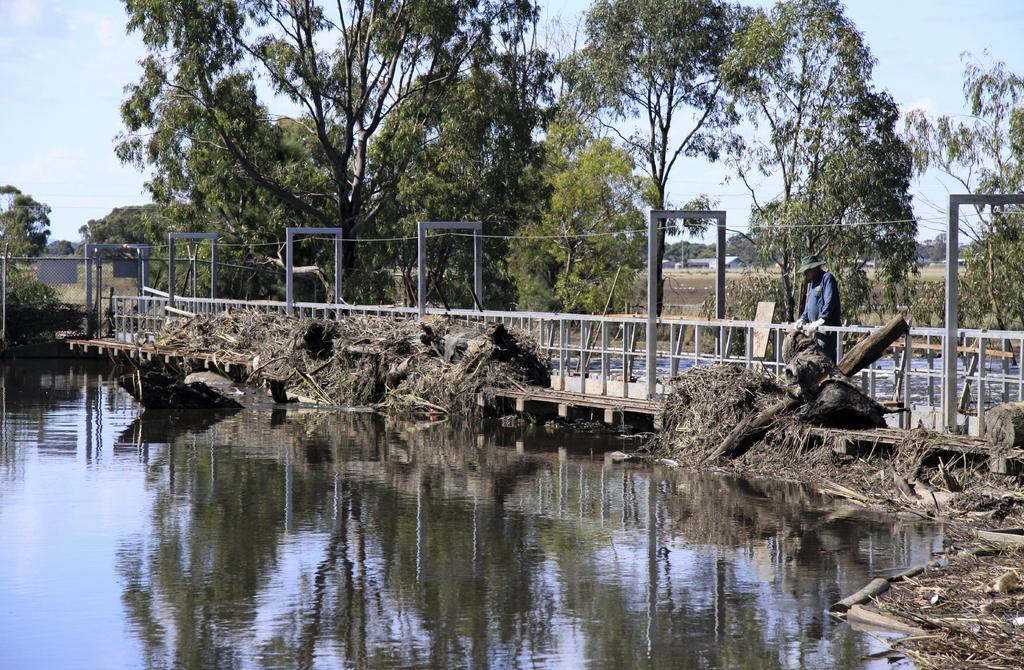Who is present in the image? There is a man in the image. Where is the man located in the image? The man is on the right side of the image. What is the man doing in the image? The man is looking at something in the water. What can be seen in the background of the image? The background of the image is the sky. What type of fan is the man holding in the image? There is no fan present in the image; the man is looking at something in the water. Is the man wearing a crown in the image? There is no crown visible on the man in the image. 